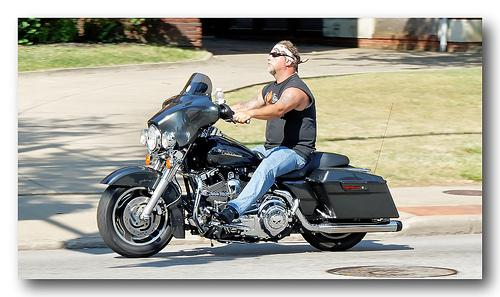Question: what is the man doing?
Choices:
A. Driving a car.
B. Riding a motorcycle.
C. Riding a bicycle.
D. Riding a tricycle.
Answer with the letter. Answer: B Question: where is he riding?
Choices:
A. In the street.
B. On the sidewalk.
C. In the park.
D. In town.
Answer with the letter. Answer: A Question: what color is the man's shirt?
Choices:
A. White.
B. Black.
C. Blue.
D. Tan.
Answer with the letter. Answer: B Question: where is the bandana?
Choices:
A. Around the man's neck.
B. On the man's motorcycle.
C. Under his helmet.
D. On the man's head.
Answer with the letter. Answer: D Question: what is in the background?
Choices:
A. House.
B. Fence.
C. Driveway.
D. Street.
Answer with the letter. Answer: C 